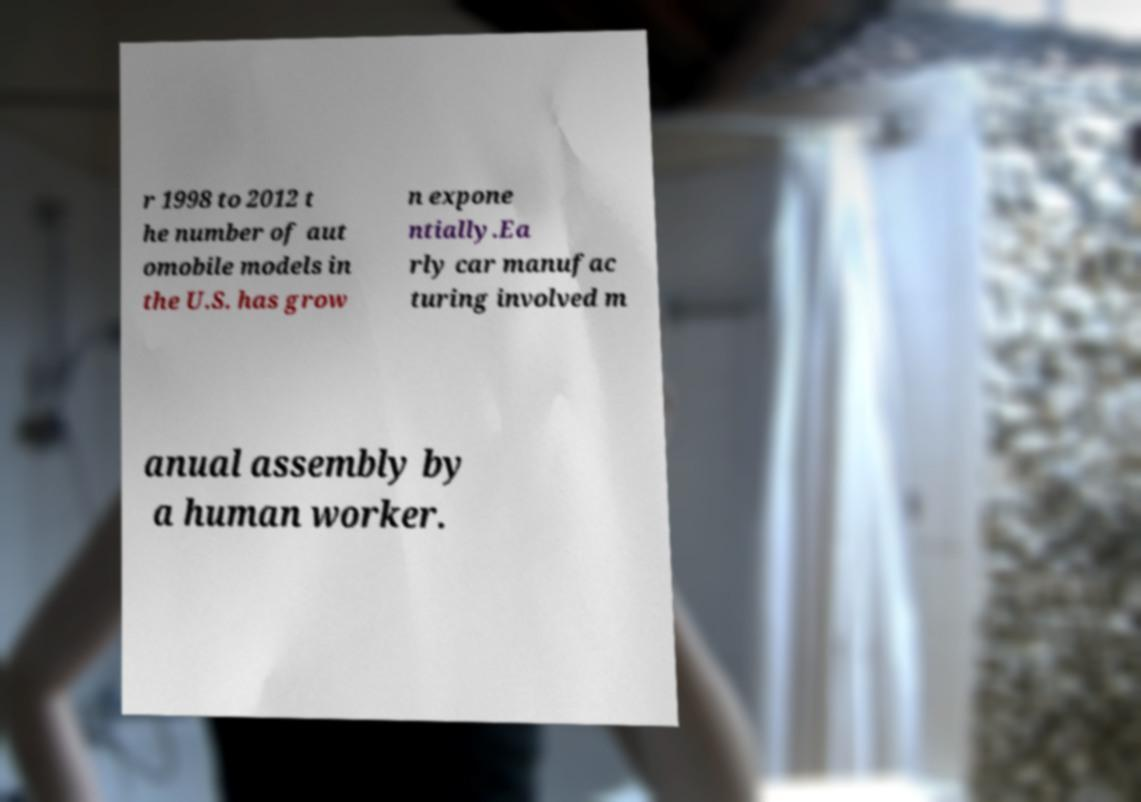There's text embedded in this image that I need extracted. Can you transcribe it verbatim? r 1998 to 2012 t he number of aut omobile models in the U.S. has grow n expone ntially.Ea rly car manufac turing involved m anual assembly by a human worker. 